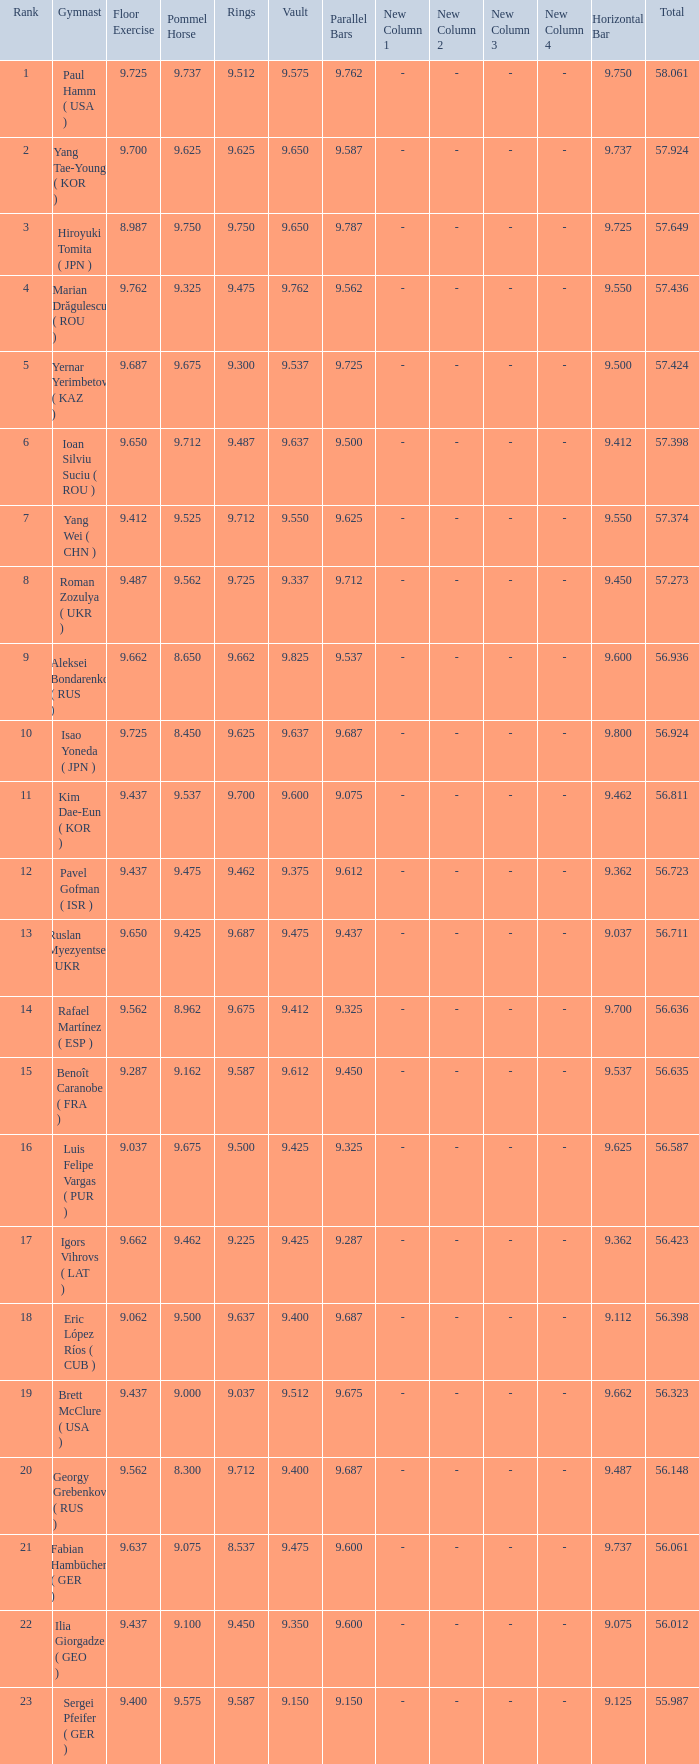Give me the full table as a dictionary. {'header': ['Rank', 'Gymnast', 'Floor Exercise', 'Pommel Horse', 'Rings', 'Vault', 'Parallel Bars', 'New Column 1', 'New Column 2', 'New Column 3', 'New Column 4', 'Horizontal Bar', 'Total'], 'rows': [['1', 'Paul Hamm ( USA )', '9.725', '9.737', '9.512', '9.575', '9.762', '-', '-', '-', '-', '9.750', '58.061'], ['2', 'Yang Tae-Young ( KOR )', '9.700', '9.625', '9.625', '9.650', '9.587', '-', '-', '-', '-', '9.737', '57.924'], ['3', 'Hiroyuki Tomita ( JPN )', '8.987', '9.750', '9.750', '9.650', '9.787', '-', '-', '-', '-', '9.725', '57.649'], ['4', 'Marian Drăgulescu ( ROU )', '9.762', '9.325', '9.475', '9.762', '9.562', '-', '-', '-', '-', '9.550', '57.436'], ['5', 'Yernar Yerimbetov ( KAZ )', '9.687', '9.675', '9.300', '9.537', '9.725', '-', '-', '-', '-', '9.500', '57.424'], ['6', 'Ioan Silviu Suciu ( ROU )', '9.650', '9.712', '9.487', '9.637', '9.500', '-', '-', '-', '-', '9.412', '57.398'], ['7', 'Yang Wei ( CHN )', '9.412', '9.525', '9.712', '9.550', '9.625', '-', '-', '-', '-', '9.550', '57.374'], ['8', 'Roman Zozulya ( UKR )', '9.487', '9.562', '9.725', '9.337', '9.712', '-', '-', '-', '-', '9.450', '57.273'], ['9', 'Aleksei Bondarenko ( RUS )', '9.662', '8.650', '9.662', '9.825', '9.537', '-', '-', '-', '-', '9.600', '56.936'], ['10', 'Isao Yoneda ( JPN )', '9.725', '8.450', '9.625', '9.637', '9.687', '-', '-', '-', '-', '9.800', '56.924'], ['11', 'Kim Dae-Eun ( KOR )', '9.437', '9.537', '9.700', '9.600', '9.075', '-', '-', '-', '-', '9.462', '56.811'], ['12', 'Pavel Gofman ( ISR )', '9.437', '9.475', '9.462', '9.375', '9.612', '-', '-', '-', '-', '9.362', '56.723'], ['13', 'Ruslan Myezyentsev ( UKR )', '9.650', '9.425', '9.687', '9.475', '9.437', '-', '-', '-', '-', '9.037', '56.711'], ['14', 'Rafael Martínez ( ESP )', '9.562', '8.962', '9.675', '9.412', '9.325', '-', '-', '-', '-', '9.700', '56.636'], ['15', 'Benoît Caranobe ( FRA )', '9.287', '9.162', '9.587', '9.612', '9.450', '-', '-', '-', '-', '9.537', '56.635'], ['16', 'Luis Felipe Vargas ( PUR )', '9.037', '9.675', '9.500', '9.425', '9.325', '-', '-', '-', '-', '9.625', '56.587'], ['17', 'Igors Vihrovs ( LAT )', '9.662', '9.462', '9.225', '9.425', '9.287', '-', '-', '-', '-', '9.362', '56.423'], ['18', 'Eric López Ríos ( CUB )', '9.062', '9.500', '9.637', '9.400', '9.687', '-', '-', '-', '-', '9.112', '56.398'], ['19', 'Brett McClure ( USA )', '9.437', '9.000', '9.037', '9.512', '9.675', '-', '-', '-', '-', '9.662', '56.323'], ['20', 'Georgy Grebenkov ( RUS )', '9.562', '8.300', '9.712', '9.400', '9.687', '-', '-', '-', '-', '9.487', '56.148'], ['21', 'Fabian Hambüchen ( GER )', '9.637', '9.075', '8.537', '9.475', '9.600', '-', '-', '-', '-', '9.737', '56.061'], ['22', 'Ilia Giorgadze ( GEO )', '9.437', '9.100', '9.450', '9.350', '9.600', '-', '-', '-', '-', '9.075', '56.012'], ['23', 'Sergei Pfeifer ( GER )', '9.400', '9.575', '9.587', '9.150', '9.150', '-', '-', '-', '-', '9.125', '55.987']]} What is the total score when the score for floor exercise was 9.287? 56.635. 